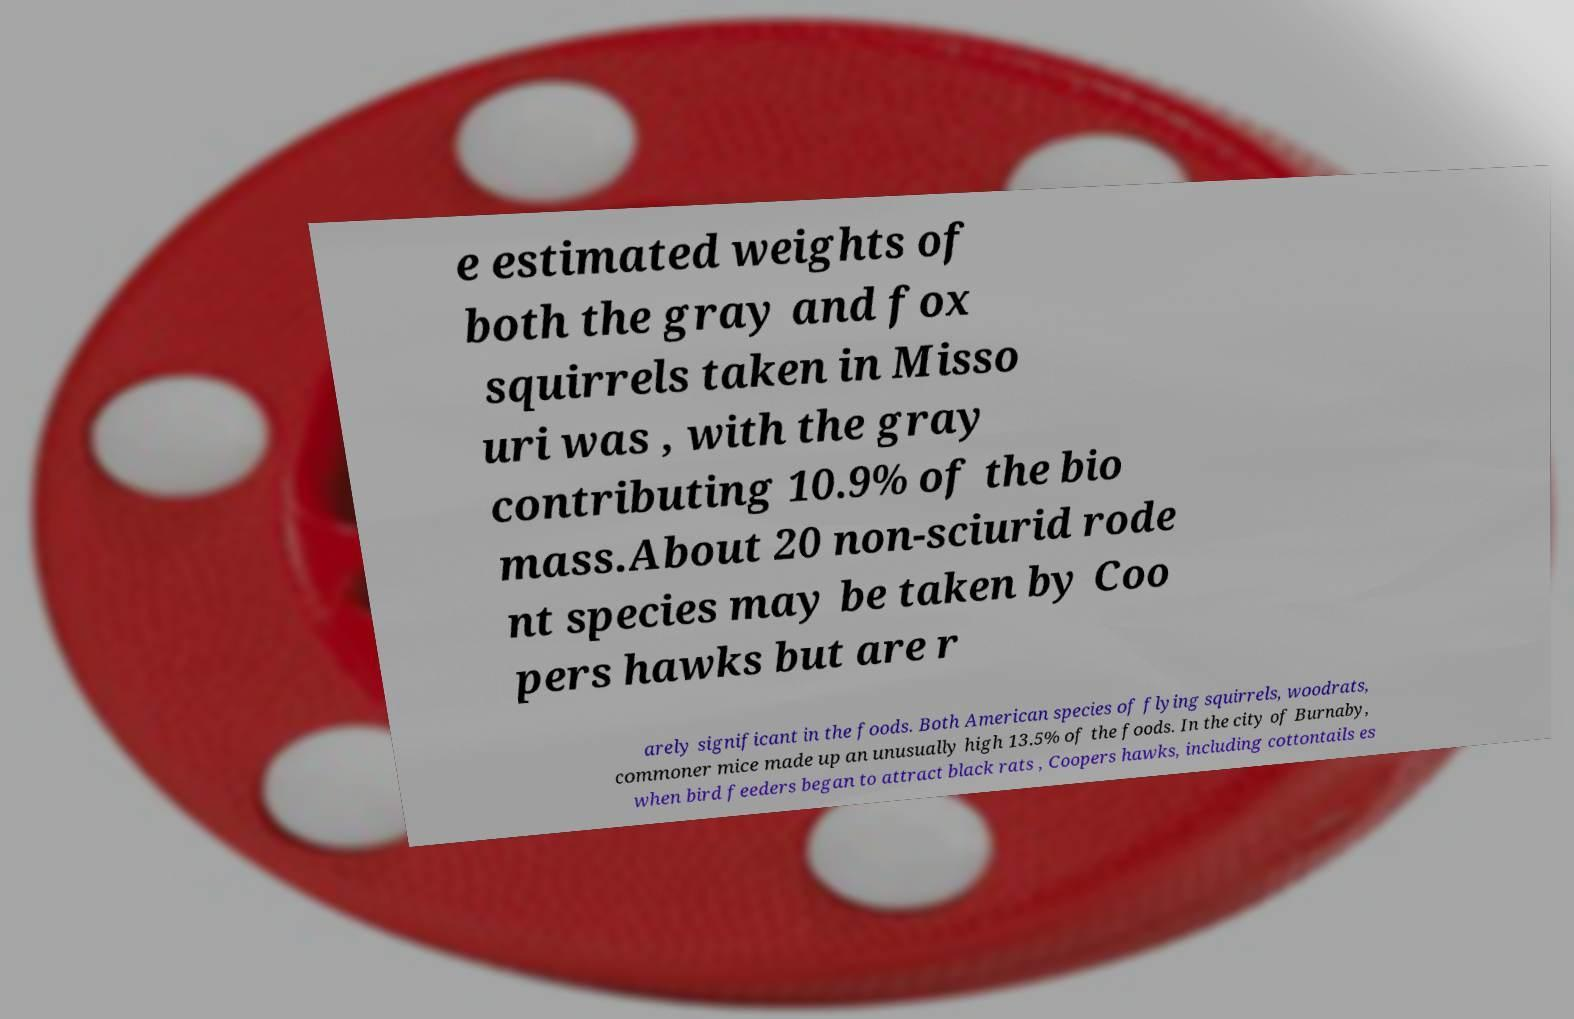Please identify and transcribe the text found in this image. e estimated weights of both the gray and fox squirrels taken in Misso uri was , with the gray contributing 10.9% of the bio mass.About 20 non-sciurid rode nt species may be taken by Coo pers hawks but are r arely significant in the foods. Both American species of flying squirrels, woodrats, commoner mice made up an unusually high 13.5% of the foods. In the city of Burnaby, when bird feeders began to attract black rats , Coopers hawks, including cottontails es 